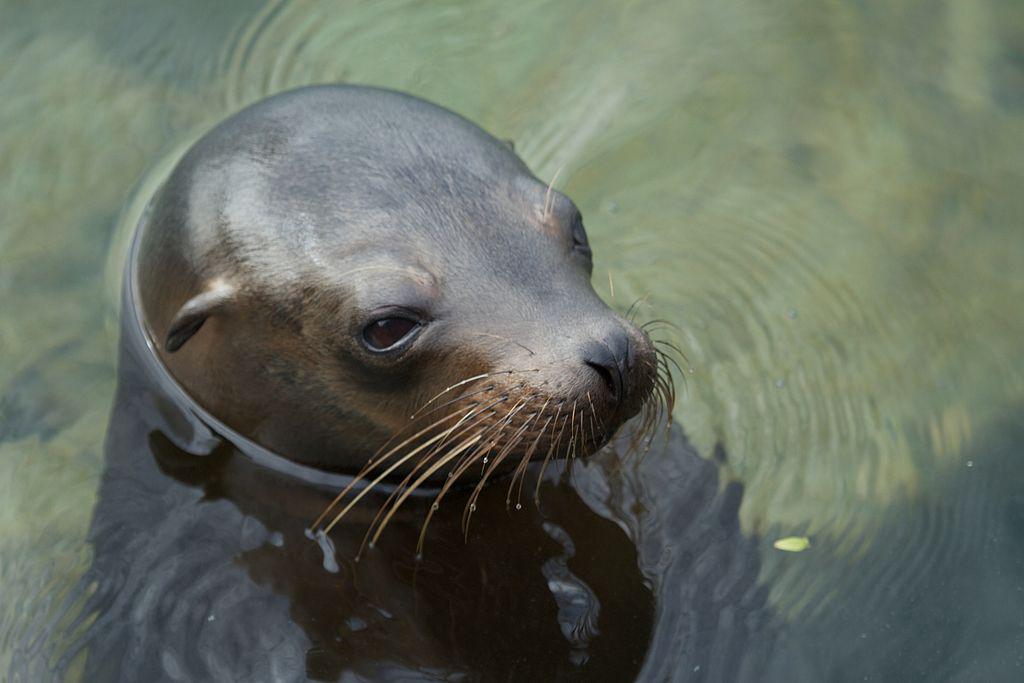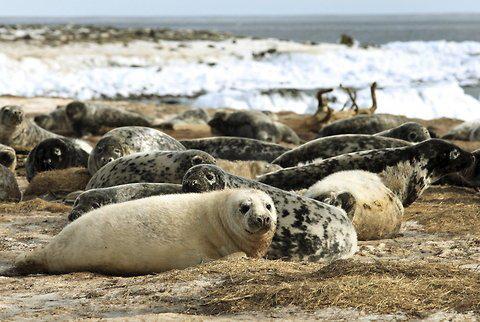The first image is the image on the left, the second image is the image on the right. Given the left and right images, does the statement "Each image includes a seal with upright head and shoulders, and no seals are in the water." hold true? Answer yes or no. No. The first image is the image on the left, the second image is the image on the right. Given the left and right images, does the statement "None of the pictures have more than two seals in them." hold true? Answer yes or no. No. 